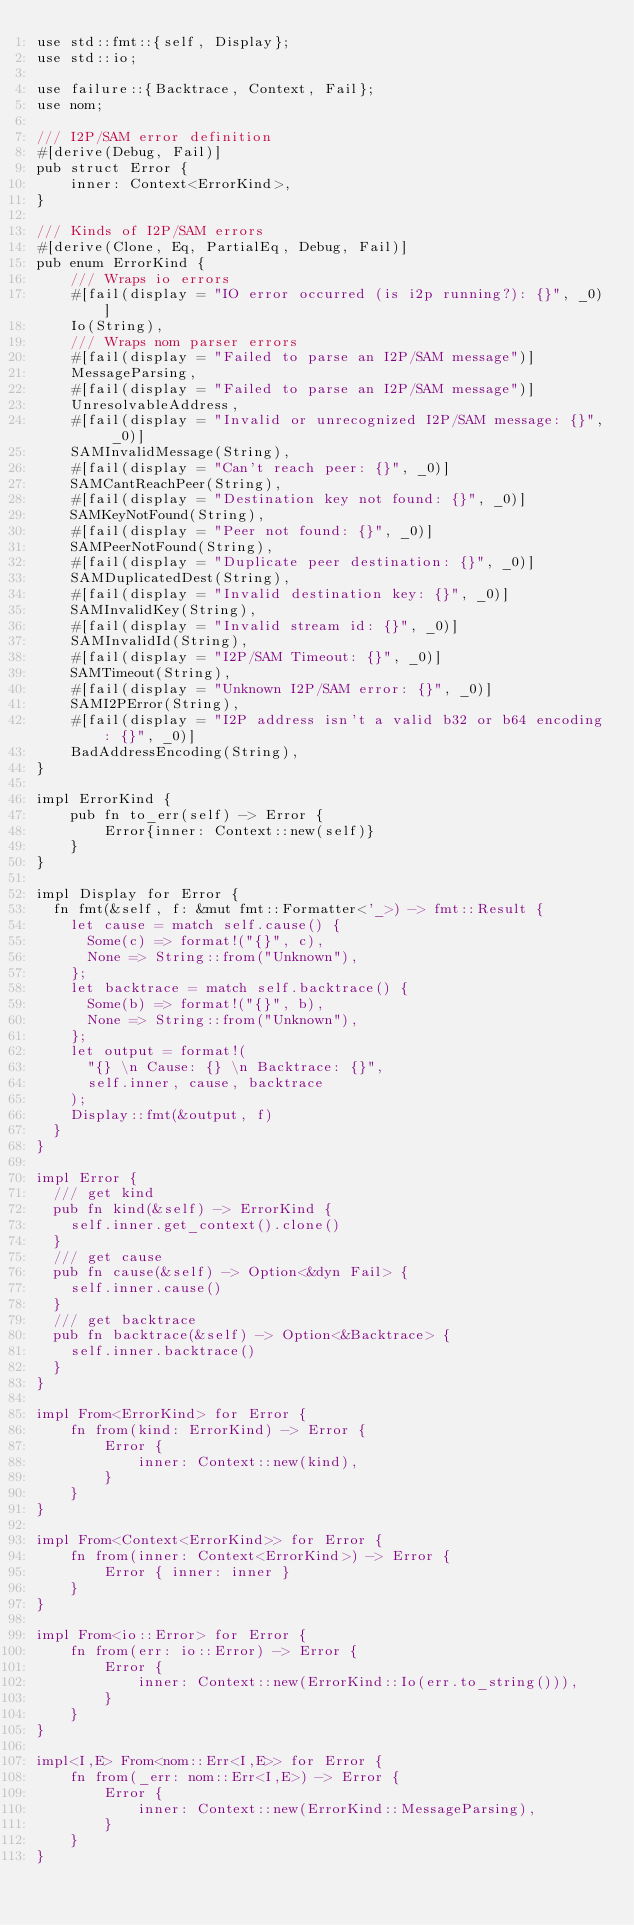<code> <loc_0><loc_0><loc_500><loc_500><_Rust_>use std::fmt::{self, Display};
use std::io;

use failure::{Backtrace, Context, Fail};
use nom;

/// I2P/SAM error definition
#[derive(Debug, Fail)]
pub struct Error {
	inner: Context<ErrorKind>,
}

/// Kinds of I2P/SAM errors
#[derive(Clone, Eq, PartialEq, Debug, Fail)]
pub enum ErrorKind {
	/// Wraps io errors
	#[fail(display = "IO error occurred (is i2p running?): {}", _0)]
	Io(String),
	/// Wraps nom parser errors
	#[fail(display = "Failed to parse an I2P/SAM message")]
	MessageParsing,
	#[fail(display = "Failed to parse an I2P/SAM message")]
	UnresolvableAddress,
	#[fail(display = "Invalid or unrecognized I2P/SAM message: {}", _0)]
	SAMInvalidMessage(String),
	#[fail(display = "Can't reach peer: {}", _0)]
	SAMCantReachPeer(String),
	#[fail(display = "Destination key not found: {}", _0)]
	SAMKeyNotFound(String),
	#[fail(display = "Peer not found: {}", _0)]
	SAMPeerNotFound(String),
	#[fail(display = "Duplicate peer destination: {}", _0)]
	SAMDuplicatedDest(String),
	#[fail(display = "Invalid destination key: {}", _0)]
	SAMInvalidKey(String),
	#[fail(display = "Invalid stream id: {}", _0)]
	SAMInvalidId(String),
	#[fail(display = "I2P/SAM Timeout: {}", _0)]
	SAMTimeout(String),
	#[fail(display = "Unknown I2P/SAM error: {}", _0)]
	SAMI2PError(String),
	#[fail(display = "I2P address isn't a valid b32 or b64 encoding: {}", _0)]
	BadAddressEncoding(String),
}

impl ErrorKind {
	pub fn to_err(self) -> Error {
		Error{inner: Context::new(self)}
	}
}

impl Display for Error {
  fn fmt(&self, f: &mut fmt::Formatter<'_>) -> fmt::Result {
    let cause = match self.cause() {
      Some(c) => format!("{}", c),
      None => String::from("Unknown"),
    };
    let backtrace = match self.backtrace() {
      Some(b) => format!("{}", b),
      None => String::from("Unknown"),
    };
    let output = format!(
      "{} \n Cause: {} \n Backtrace: {}",
      self.inner, cause, backtrace
    );
    Display::fmt(&output, f)
  }
}

impl Error {
  /// get kind
  pub fn kind(&self) -> ErrorKind {
    self.inner.get_context().clone()
  }
  /// get cause
  pub fn cause(&self) -> Option<&dyn Fail> {
    self.inner.cause()
  }
  /// get backtrace
  pub fn backtrace(&self) -> Option<&Backtrace> {
    self.inner.backtrace()
  }
}

impl From<ErrorKind> for Error {
	fn from(kind: ErrorKind) -> Error {
		Error {
			inner: Context::new(kind),
		}
	}
}

impl From<Context<ErrorKind>> for Error {
	fn from(inner: Context<ErrorKind>) -> Error {
		Error { inner: inner }
	}
}

impl From<io::Error> for Error {
	fn from(err: io::Error) -> Error {
		Error {
			inner: Context::new(ErrorKind::Io(err.to_string())),
		}
	}
}

impl<I,E> From<nom::Err<I,E>> for Error {
	fn from(_err: nom::Err<I,E>) -> Error {
		Error {
			inner: Context::new(ErrorKind::MessageParsing),
		}
	}
}
</code> 